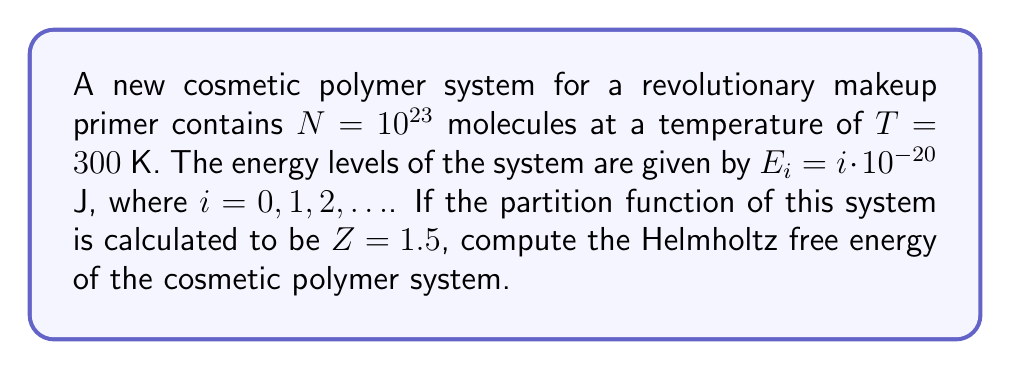Teach me how to tackle this problem. To solve this problem, we'll follow these steps:

1) The Helmholtz free energy $F$ is defined as:

   $$F = -k_B T \ln Z$$

   where $k_B$ is the Boltzmann constant, $T$ is the temperature, and $Z$ is the partition function.

2) We're given:
   - Temperature $T = 300$ K
   - Partition function $Z = 1.5$

3) We need to use the Boltzmann constant:
   $k_B = 1.380649 \times 10^{-23}$ J/K

4) Now, let's substitute these values into the equation:

   $$F = -(1.380649 \times 10^{-23} \text{ J/K})(300 \text{ K})(\ln 1.5)$$

5) Calculate $\ln 1.5$:
   $\ln 1.5 \approx 0.4054651$

6) Multiply all the values:

   $$F = -(1.380649 \times 10^{-23})(300)(0.4054651)$$
   $$F = -1.6783 \times 10^{-21} \text{ J}$$

7) The negative sign indicates that this amount of energy could be extracted from the system to do work while keeping the temperature constant.
Answer: $-1.6783 \times 10^{-21}$ J 